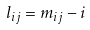Convert formula to latex. <formula><loc_0><loc_0><loc_500><loc_500>l _ { i j } = m _ { i j } - i</formula> 